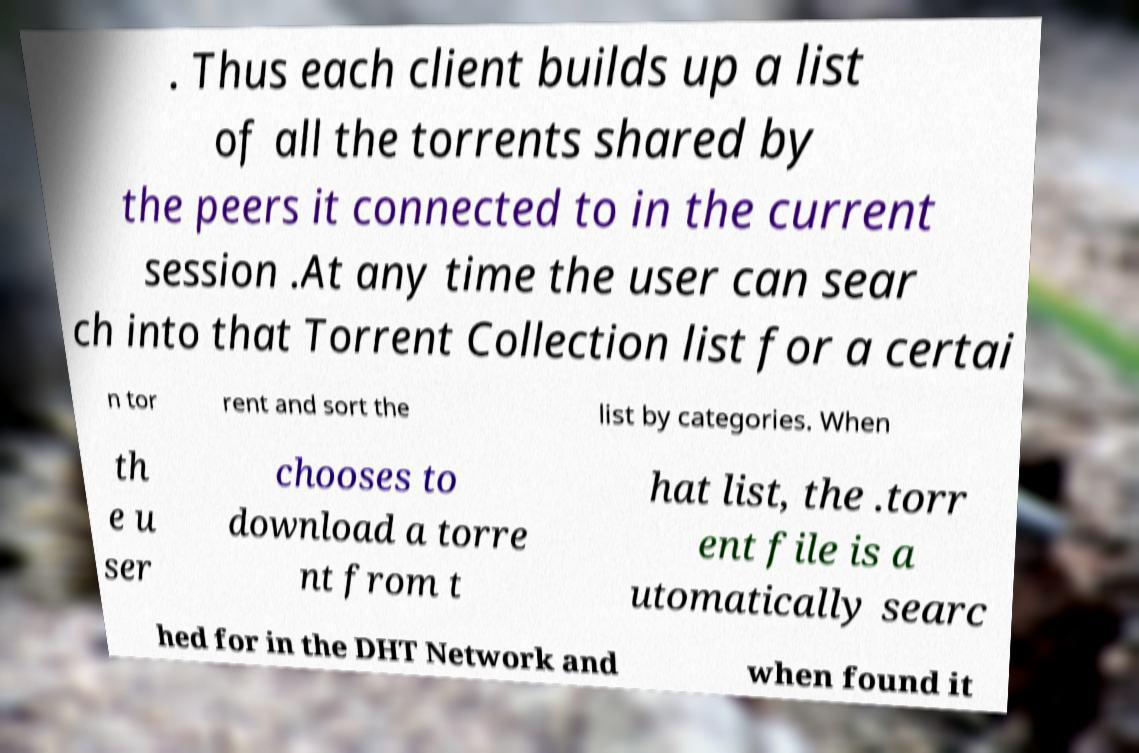Please identify and transcribe the text found in this image. . Thus each client builds up a list of all the torrents shared by the peers it connected to in the current session .At any time the user can sear ch into that Torrent Collection list for a certai n tor rent and sort the list by categories. When th e u ser chooses to download a torre nt from t hat list, the .torr ent file is a utomatically searc hed for in the DHT Network and when found it 